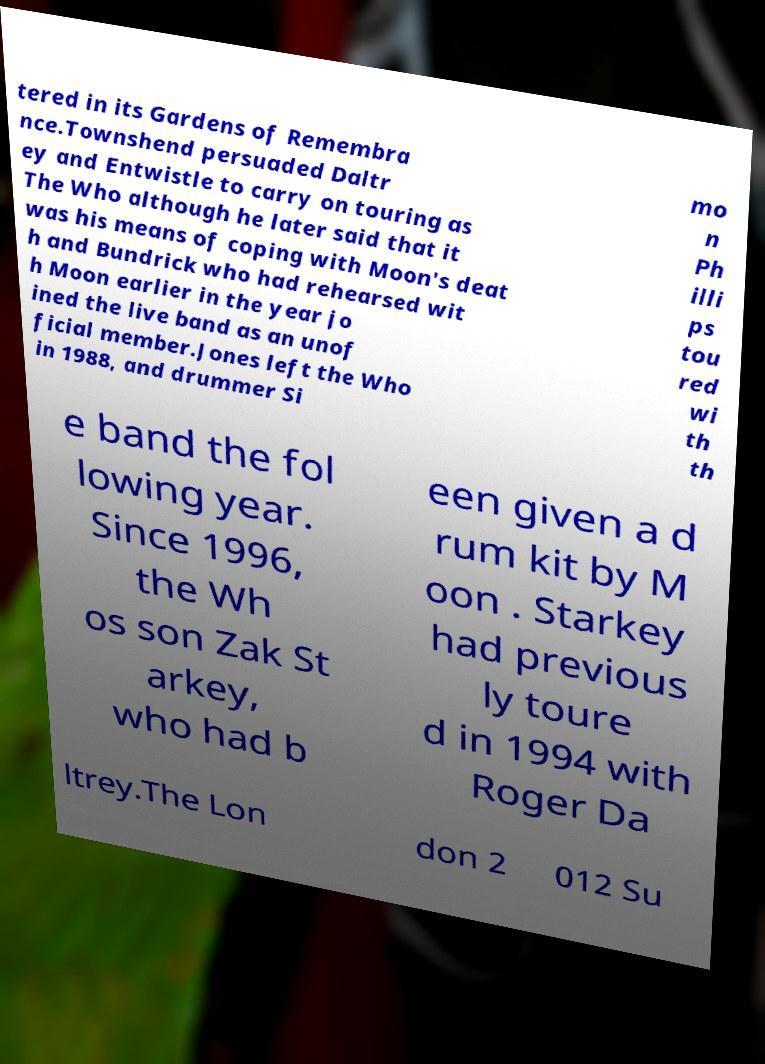Could you assist in decoding the text presented in this image and type it out clearly? tered in its Gardens of Remembra nce.Townshend persuaded Daltr ey and Entwistle to carry on touring as The Who although he later said that it was his means of coping with Moon's deat h and Bundrick who had rehearsed wit h Moon earlier in the year jo ined the live band as an unof ficial member.Jones left the Who in 1988, and drummer Si mo n Ph illi ps tou red wi th th e band the fol lowing year. Since 1996, the Wh os son Zak St arkey, who had b een given a d rum kit by M oon . Starkey had previous ly toure d in 1994 with Roger Da ltrey.The Lon don 2 012 Su 